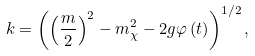Convert formula to latex. <formula><loc_0><loc_0><loc_500><loc_500>k = \left ( \left ( \frac { m } { 2 } \right ) ^ { 2 } - m _ { \chi } ^ { 2 } - 2 g \varphi \left ( t \right ) \right ) ^ { 1 / 2 } ,</formula> 